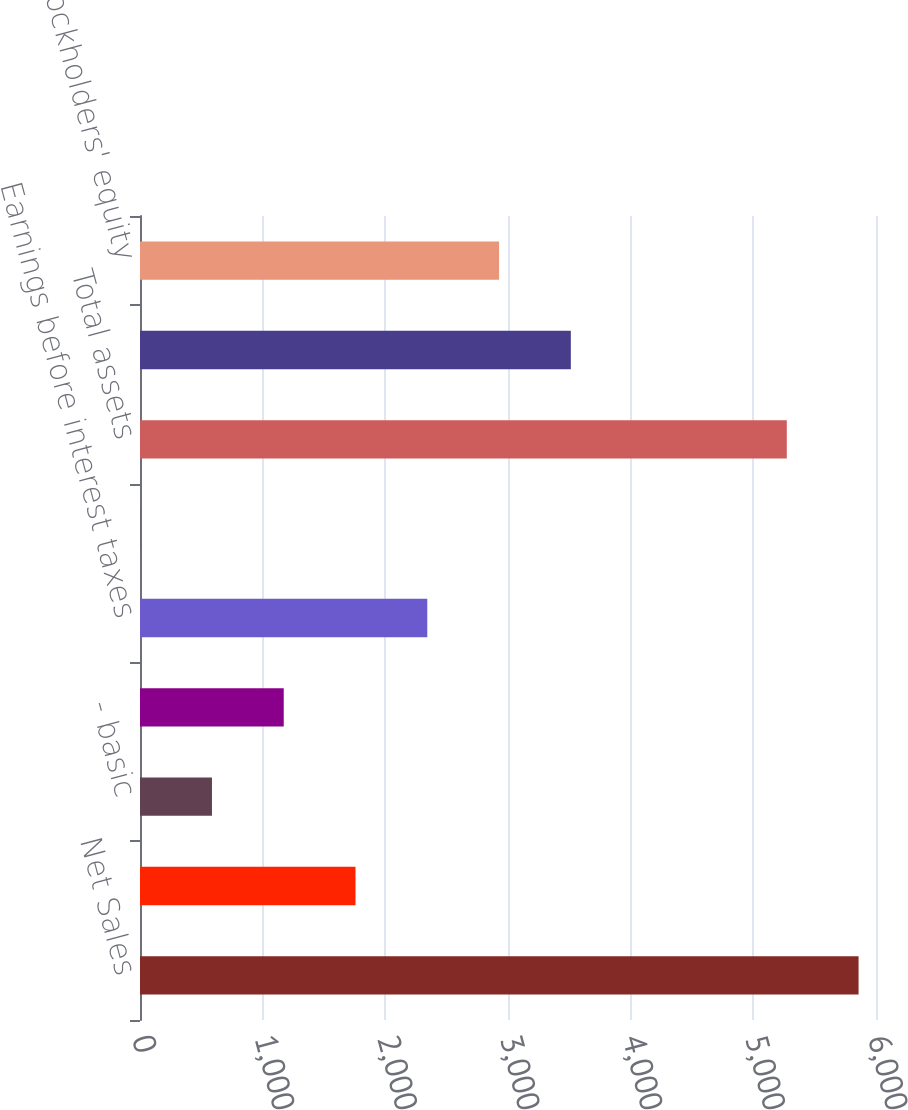Convert chart to OTSL. <chart><loc_0><loc_0><loc_500><loc_500><bar_chart><fcel>Net Sales<fcel>Net Income<fcel>- basic<fcel>- diluted<fcel>Earnings before interest taxes<fcel>Cash dividends declared per<fcel>Total assets<fcel>Total debt obligations<fcel>Stockholders' equity<nl><fcel>5857.9<fcel>1756.9<fcel>586.7<fcel>1171.8<fcel>2342<fcel>1.6<fcel>5272.8<fcel>3512.2<fcel>2927.1<nl></chart> 